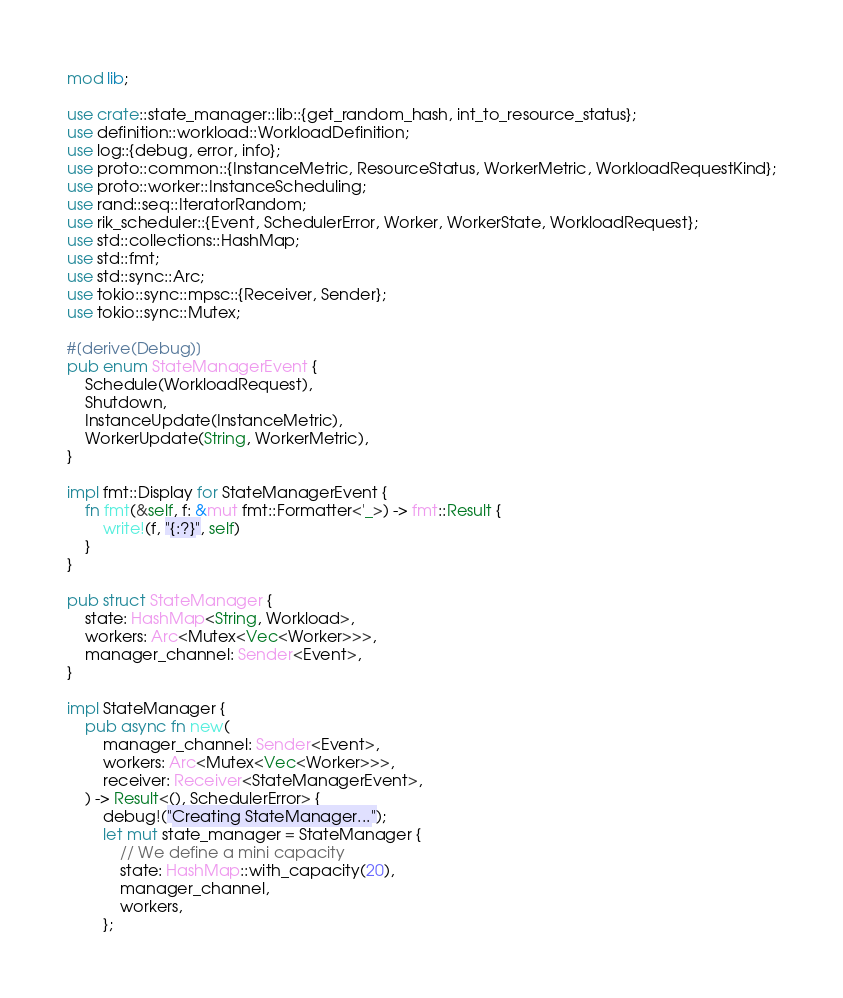Convert code to text. <code><loc_0><loc_0><loc_500><loc_500><_Rust_>mod lib;

use crate::state_manager::lib::{get_random_hash, int_to_resource_status};
use definition::workload::WorkloadDefinition;
use log::{debug, error, info};
use proto::common::{InstanceMetric, ResourceStatus, WorkerMetric, WorkloadRequestKind};
use proto::worker::InstanceScheduling;
use rand::seq::IteratorRandom;
use rik_scheduler::{Event, SchedulerError, Worker, WorkerState, WorkloadRequest};
use std::collections::HashMap;
use std::fmt;
use std::sync::Arc;
use tokio::sync::mpsc::{Receiver, Sender};
use tokio::sync::Mutex;

#[derive(Debug)]
pub enum StateManagerEvent {
    Schedule(WorkloadRequest),
    Shutdown,
    InstanceUpdate(InstanceMetric),
    WorkerUpdate(String, WorkerMetric),
}

impl fmt::Display for StateManagerEvent {
    fn fmt(&self, f: &mut fmt::Formatter<'_>) -> fmt::Result {
        write!(f, "{:?}", self)
    }
}

pub struct StateManager {
    state: HashMap<String, Workload>,
    workers: Arc<Mutex<Vec<Worker>>>,
    manager_channel: Sender<Event>,
}

impl StateManager {
    pub async fn new(
        manager_channel: Sender<Event>,
        workers: Arc<Mutex<Vec<Worker>>>,
        receiver: Receiver<StateManagerEvent>,
    ) -> Result<(), SchedulerError> {
        debug!("Creating StateManager...");
        let mut state_manager = StateManager {
            // We define a mini capacity
            state: HashMap::with_capacity(20),
            manager_channel,
            workers,
        };</code> 